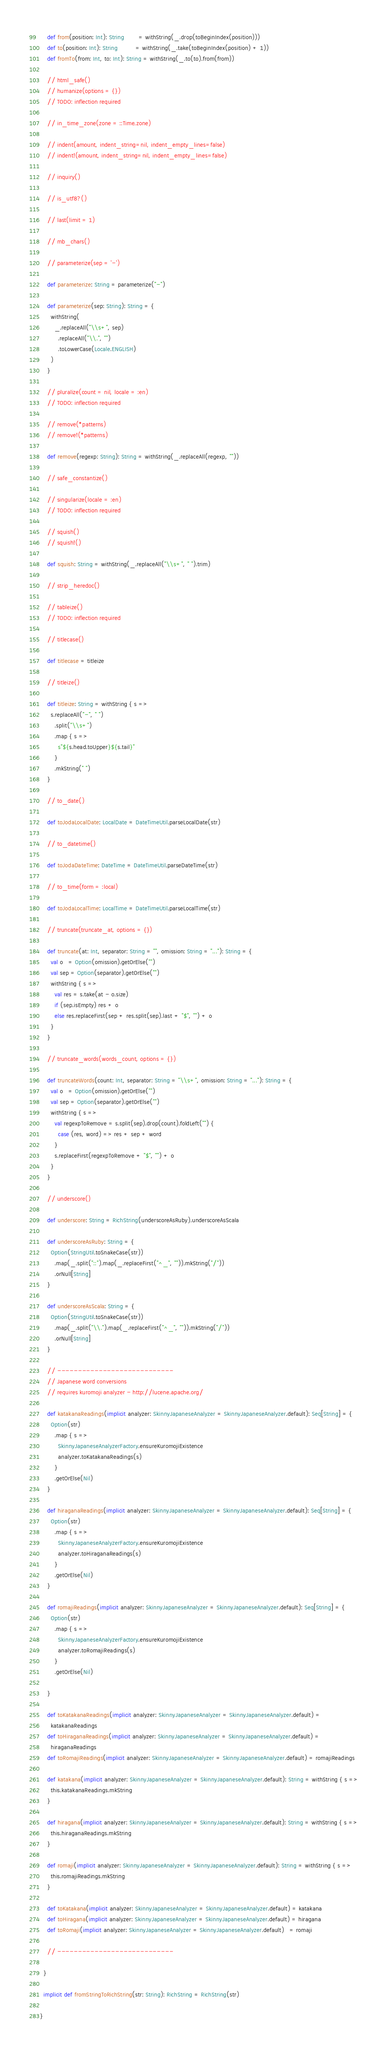<code> <loc_0><loc_0><loc_500><loc_500><_Scala_>    def from(position: Int): String        = withString(_.drop(toBeginIndex(position)))
    def to(position: Int): String          = withString(_.take(toBeginIndex(position) + 1))
    def fromTo(from: Int, to: Int): String = withString(_.to(to).from(from))

    // html_safe()
    // humanize(options = {})
    // TODO: inflection required

    // in_time_zone(zone = ::Time.zone)

    // indent(amount, indent_string=nil, indent_empty_lines=false)
    // indent!(amount, indent_string=nil, indent_empty_lines=false)

    // inquiry()

    // is_utf8?()

    // last(limit = 1)

    // mb_chars()

    // parameterize(sep = '-')

    def parameterize: String = parameterize("-")

    def parameterize(sep: String): String = {
      withString(
        _.replaceAll("\\s+", sep)
          .replaceAll("\\.", "")
          .toLowerCase(Locale.ENGLISH)
      )
    }

    // pluralize(count = nil, locale = :en)
    // TODO: inflection required

    // remove(*patterns)
    // remove!(*patterns)

    def remove(regexp: String): String = withString(_.replaceAll(regexp, ""))

    // safe_constantize()

    // singularize(locale = :en)
    // TODO: inflection required

    // squish()
    // squish!()

    def squish: String = withString(_.replaceAll("\\s+", " ").trim)

    // strip_heredoc()

    // tableize()
    // TODO: inflection required

    // titlecase()

    def titlecase = titleize

    // titleize()

    def titleize: String = withString { s =>
      s.replaceAll("-", " ")
        .split("\\s+")
        .map { s =>
          s"${s.head.toUpper}${s.tail}"
        }
        .mkString(" ")
    }

    // to_date()

    def toJodaLocalDate: LocalDate = DateTimeUtil.parseLocalDate(str)

    // to_datetime()

    def toJodaDateTime: DateTime = DateTimeUtil.parseDateTime(str)

    // to_time(form = :local)

    def toJodaLocalTime: LocalTime = DateTimeUtil.parseLocalTime(str)

    // truncate(truncate_at, options = {})

    def truncate(at: Int, separator: String = "", omission: String = "..."): String = {
      val o   = Option(omission).getOrElse("")
      val sep = Option(separator).getOrElse("")
      withString { s =>
        val res = s.take(at - o.size)
        if (sep.isEmpty) res + o
        else res.replaceFirst(sep + res.split(sep).last + "$", "") + o
      }
    }

    // truncate_words(words_count, options = {})

    def truncateWords(count: Int, separator: String = "\\s+", omission: String = "..."): String = {
      val o   = Option(omission).getOrElse("")
      val sep = Option(separator).getOrElse("")
      withString { s =>
        val regexpToRemove = s.split(sep).drop(count).foldLeft("") {
          case (res, word) => res + sep + word
        }
        s.replaceFirst(regexpToRemove + "$", "") + o
      }
    }

    // underscore()

    def underscore: String = RichString(underscoreAsRuby).underscoreAsScala

    def underscoreAsRuby: String = {
      Option(StringUtil.toSnakeCase(str))
        .map(_.split("::").map(_.replaceFirst("^_", "")).mkString("/"))
        .orNull[String]
    }

    def underscoreAsScala: String = {
      Option(StringUtil.toSnakeCase(str))
        .map(_.split("\\.").map(_.replaceFirst("^_", "")).mkString("/"))
        .orNull[String]
    }

    // ----------------------------
    // Japanese word conversions
    // requires kuromoji analyzer - http://lucene.apache.org/

    def katakanaReadings(implicit analyzer: SkinnyJapaneseAnalyzer = SkinnyJapaneseAnalyzer.default): Seq[String] = {
      Option(str)
        .map { s =>
          SkinnyJapaneseAnalyzerFactory.ensureKuromojiExistence
          analyzer.toKatakanaReadings(s)
        }
        .getOrElse(Nil)
    }

    def hiraganaReadings(implicit analyzer: SkinnyJapaneseAnalyzer = SkinnyJapaneseAnalyzer.default): Seq[String] = {
      Option(str)
        .map { s =>
          SkinnyJapaneseAnalyzerFactory.ensureKuromojiExistence
          analyzer.toHiraganaReadings(s)
        }
        .getOrElse(Nil)
    }

    def romajiReadings(implicit analyzer: SkinnyJapaneseAnalyzer = SkinnyJapaneseAnalyzer.default): Seq[String] = {
      Option(str)
        .map { s =>
          SkinnyJapaneseAnalyzerFactory.ensureKuromojiExistence
          analyzer.toRomajiReadings(s)
        }
        .getOrElse(Nil)

    }

    def toKatakanaReadings(implicit analyzer: SkinnyJapaneseAnalyzer = SkinnyJapaneseAnalyzer.default) =
      katakanaReadings
    def toHiraganaReadings(implicit analyzer: SkinnyJapaneseAnalyzer = SkinnyJapaneseAnalyzer.default) =
      hiraganaReadings
    def toRomajiReadings(implicit analyzer: SkinnyJapaneseAnalyzer = SkinnyJapaneseAnalyzer.default) = romajiReadings

    def katakana(implicit analyzer: SkinnyJapaneseAnalyzer = SkinnyJapaneseAnalyzer.default): String = withString { s =>
      this.katakanaReadings.mkString
    }

    def hiragana(implicit analyzer: SkinnyJapaneseAnalyzer = SkinnyJapaneseAnalyzer.default): String = withString { s =>
      this.hiraganaReadings.mkString
    }

    def romaji(implicit analyzer: SkinnyJapaneseAnalyzer = SkinnyJapaneseAnalyzer.default): String = withString { s =>
      this.romajiReadings.mkString
    }

    def toKatakana(implicit analyzer: SkinnyJapaneseAnalyzer = SkinnyJapaneseAnalyzer.default) = katakana
    def toHiragana(implicit analyzer: SkinnyJapaneseAnalyzer = SkinnyJapaneseAnalyzer.default) = hiragana
    def toRomaji(implicit analyzer: SkinnyJapaneseAnalyzer = SkinnyJapaneseAnalyzer.default)   = romaji

    // ----------------------------

  }

  implicit def fromStringToRichString(str: String): RichString = RichString(str)

}
</code> 